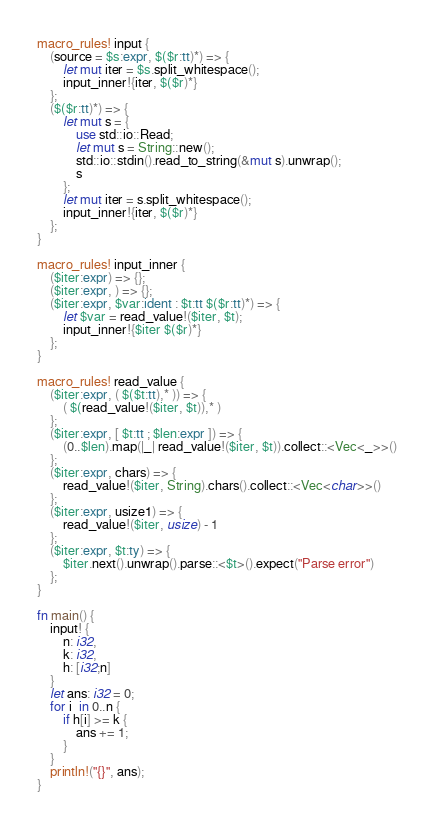Convert code to text. <code><loc_0><loc_0><loc_500><loc_500><_Rust_>macro_rules! input {
    (source = $s:expr, $($r:tt)*) => {
        let mut iter = $s.split_whitespace();
        input_inner!{iter, $($r)*}
    };
    ($($r:tt)*) => {
        let mut s = {
            use std::io::Read;
            let mut s = String::new();
            std::io::stdin().read_to_string(&mut s).unwrap();
            s
        };
        let mut iter = s.split_whitespace();
        input_inner!{iter, $($r)*}
    };
}

macro_rules! input_inner {
    ($iter:expr) => {};
    ($iter:expr, ) => {};
    ($iter:expr, $var:ident : $t:tt $($r:tt)*) => {
        let $var = read_value!($iter, $t);
        input_inner!{$iter $($r)*}
    };
}

macro_rules! read_value {
    ($iter:expr, ( $($t:tt),* )) => {
        ( $(read_value!($iter, $t)),* )
    };
    ($iter:expr, [ $t:tt ; $len:expr ]) => {
        (0..$len).map(|_| read_value!($iter, $t)).collect::<Vec<_>>()
    };
    ($iter:expr, chars) => {
        read_value!($iter, String).chars().collect::<Vec<char>>()
    };
    ($iter:expr, usize1) => {
        read_value!($iter, usize) - 1
    };
    ($iter:expr, $t:ty) => {
        $iter.next().unwrap().parse::<$t>().expect("Parse error")
    };
}

fn main() {
    input! {
        n: i32,
        k: i32,
        h: [i32;n]
    }
    let ans: i32 = 0;
    for i  in 0..n {
        if h[i] >= k {
            ans += 1;
        }
    }
    println!("{}", ans);
}</code> 